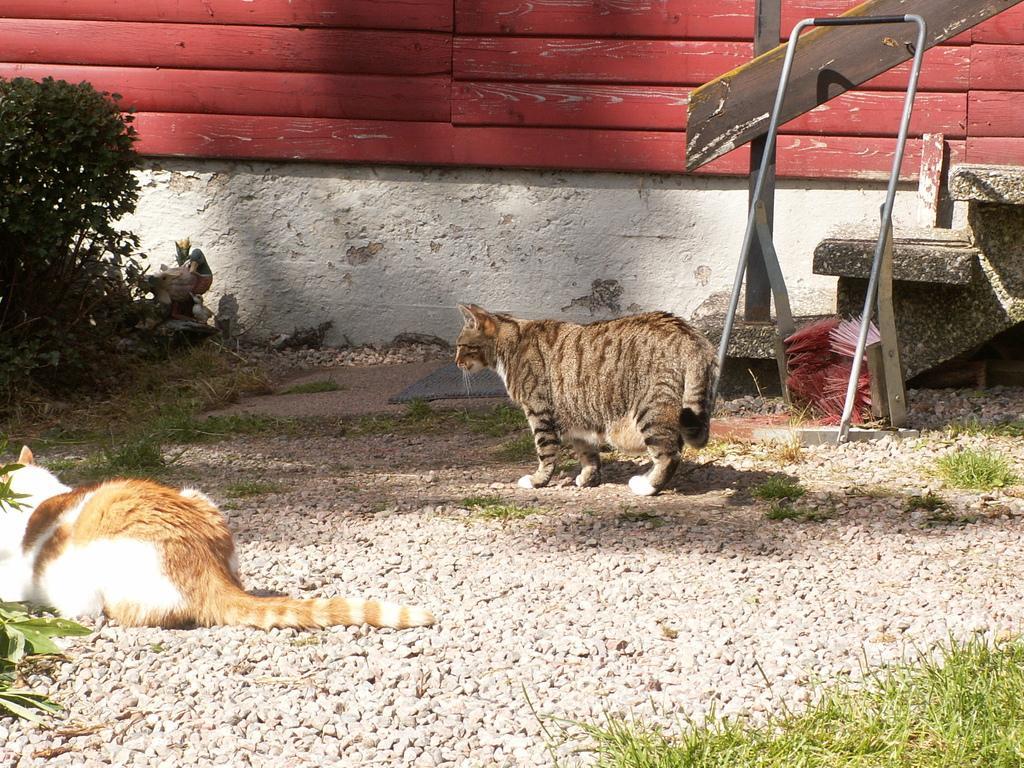In one or two sentences, can you explain what this image depicts? At the bottom of the image there are stones on the ground. And also there is a cat lying. And there is another cat walking. Behind that cat there are steps, railing and some other things. On the left side of the image there is a plant. In the background there is a wall. 